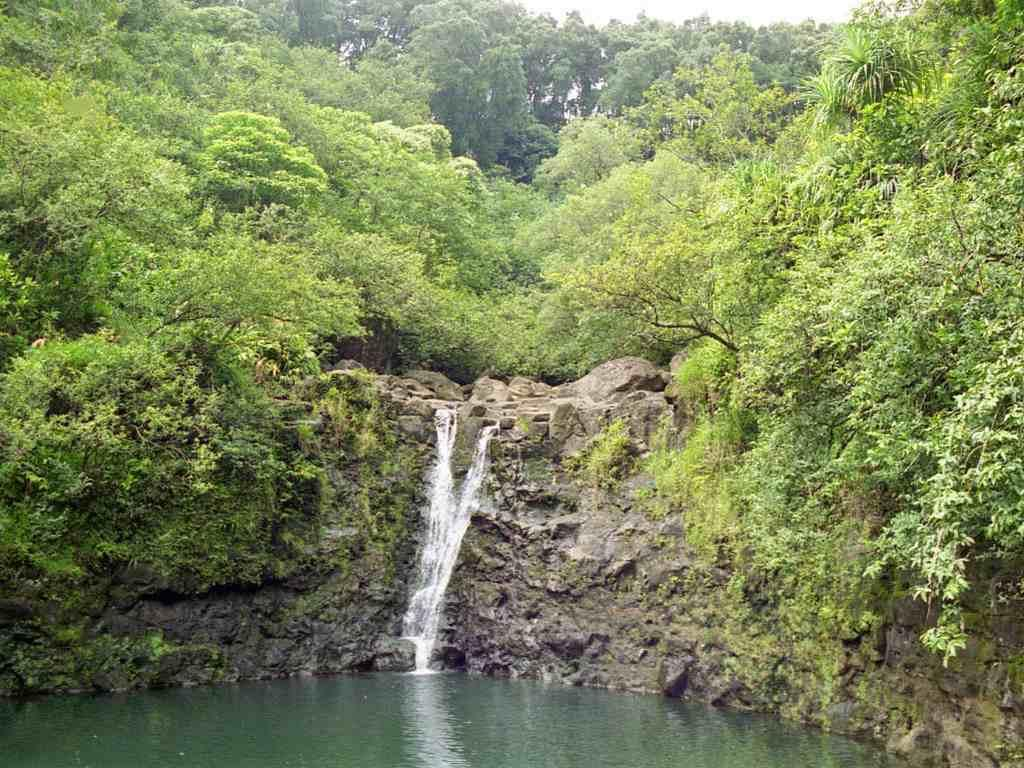What type of natural features can be seen in the image? There are trees and a waterfall in the image. What is visible in the background of the image? The sky is visible in the image. What is present at the bottom of the image? There is water at the bottom of the image. What type of office furniture can be seen in the image? There is no office furniture present in the image; it features natural elements such as trees, a waterfall, and water. What type of butter is being used to spread on the trees in the image? There is no butter present in the image, and trees do not require butter for any purpose. 